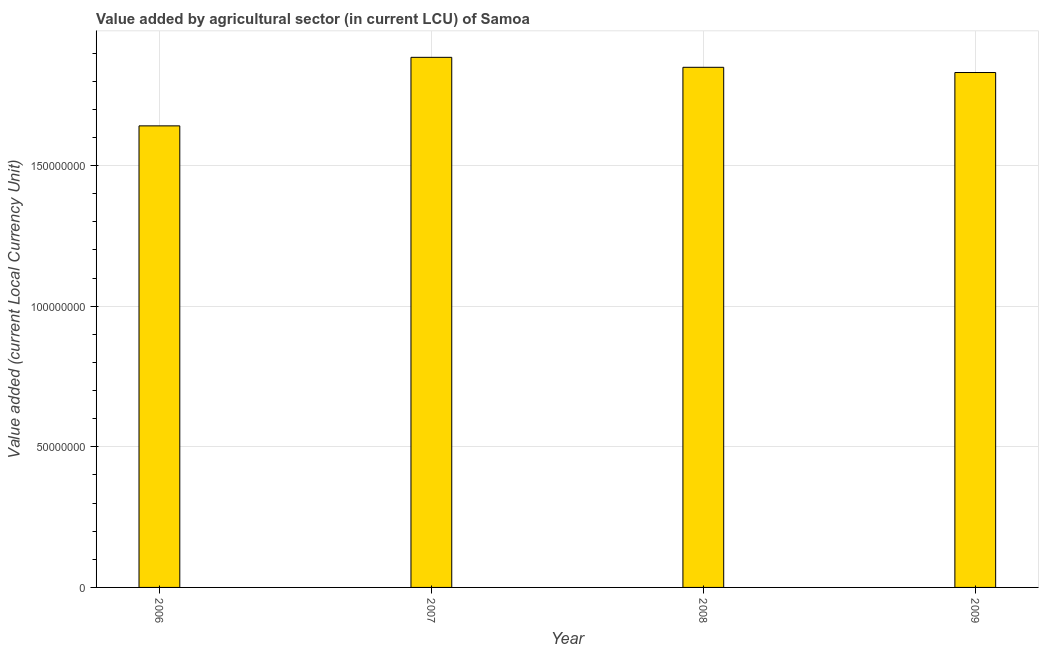What is the title of the graph?
Offer a terse response. Value added by agricultural sector (in current LCU) of Samoa. What is the label or title of the X-axis?
Ensure brevity in your answer.  Year. What is the label or title of the Y-axis?
Your response must be concise. Value added (current Local Currency Unit). What is the value added by agriculture sector in 2008?
Ensure brevity in your answer.  1.85e+08. Across all years, what is the maximum value added by agriculture sector?
Keep it short and to the point. 1.88e+08. Across all years, what is the minimum value added by agriculture sector?
Offer a terse response. 1.64e+08. What is the sum of the value added by agriculture sector?
Your answer should be very brief. 7.21e+08. What is the difference between the value added by agriculture sector in 2006 and 2007?
Provide a succinct answer. -2.44e+07. What is the average value added by agriculture sector per year?
Your answer should be compact. 1.80e+08. What is the median value added by agriculture sector?
Your answer should be compact. 1.84e+08. Do a majority of the years between 2009 and 2007 (inclusive) have value added by agriculture sector greater than 20000000 LCU?
Ensure brevity in your answer.  Yes. What is the ratio of the value added by agriculture sector in 2007 to that in 2009?
Give a very brief answer. 1.03. Is the value added by agriculture sector in 2008 less than that in 2009?
Make the answer very short. No. What is the difference between the highest and the second highest value added by agriculture sector?
Your answer should be compact. 3.54e+06. Is the sum of the value added by agriculture sector in 2006 and 2009 greater than the maximum value added by agriculture sector across all years?
Make the answer very short. Yes. What is the difference between the highest and the lowest value added by agriculture sector?
Keep it short and to the point. 2.44e+07. Are all the bars in the graph horizontal?
Provide a succinct answer. No. How many years are there in the graph?
Ensure brevity in your answer.  4. Are the values on the major ticks of Y-axis written in scientific E-notation?
Your answer should be very brief. No. What is the Value added (current Local Currency Unit) of 2006?
Give a very brief answer. 1.64e+08. What is the Value added (current Local Currency Unit) in 2007?
Your response must be concise. 1.88e+08. What is the Value added (current Local Currency Unit) of 2008?
Make the answer very short. 1.85e+08. What is the Value added (current Local Currency Unit) in 2009?
Ensure brevity in your answer.  1.83e+08. What is the difference between the Value added (current Local Currency Unit) in 2006 and 2007?
Your response must be concise. -2.44e+07. What is the difference between the Value added (current Local Currency Unit) in 2006 and 2008?
Offer a terse response. -2.08e+07. What is the difference between the Value added (current Local Currency Unit) in 2006 and 2009?
Your answer should be very brief. -1.90e+07. What is the difference between the Value added (current Local Currency Unit) in 2007 and 2008?
Your answer should be compact. 3.54e+06. What is the difference between the Value added (current Local Currency Unit) in 2007 and 2009?
Your response must be concise. 5.40e+06. What is the difference between the Value added (current Local Currency Unit) in 2008 and 2009?
Provide a short and direct response. 1.86e+06. What is the ratio of the Value added (current Local Currency Unit) in 2006 to that in 2007?
Give a very brief answer. 0.87. What is the ratio of the Value added (current Local Currency Unit) in 2006 to that in 2008?
Ensure brevity in your answer.  0.89. What is the ratio of the Value added (current Local Currency Unit) in 2006 to that in 2009?
Provide a succinct answer. 0.9. What is the ratio of the Value added (current Local Currency Unit) in 2007 to that in 2008?
Offer a very short reply. 1.02. What is the ratio of the Value added (current Local Currency Unit) in 2007 to that in 2009?
Offer a terse response. 1.03. What is the ratio of the Value added (current Local Currency Unit) in 2008 to that in 2009?
Your response must be concise. 1.01. 